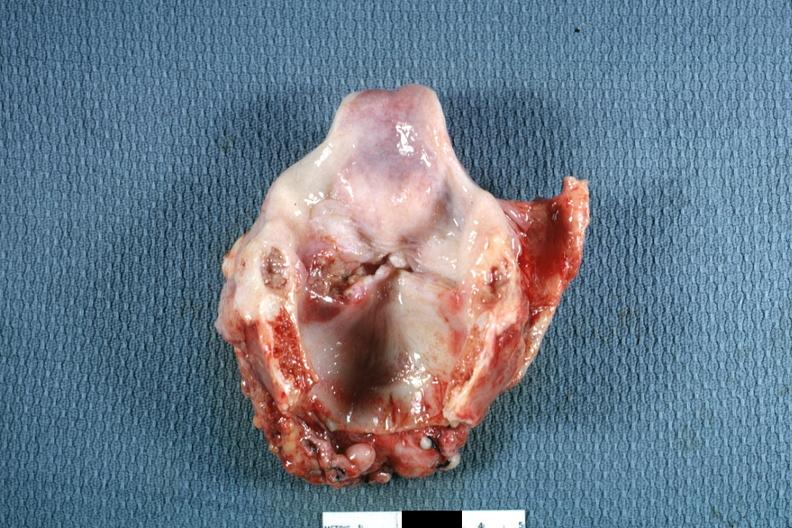does this image show ulcerative lesion left true cord quite good?
Answer the question using a single word or phrase. Yes 